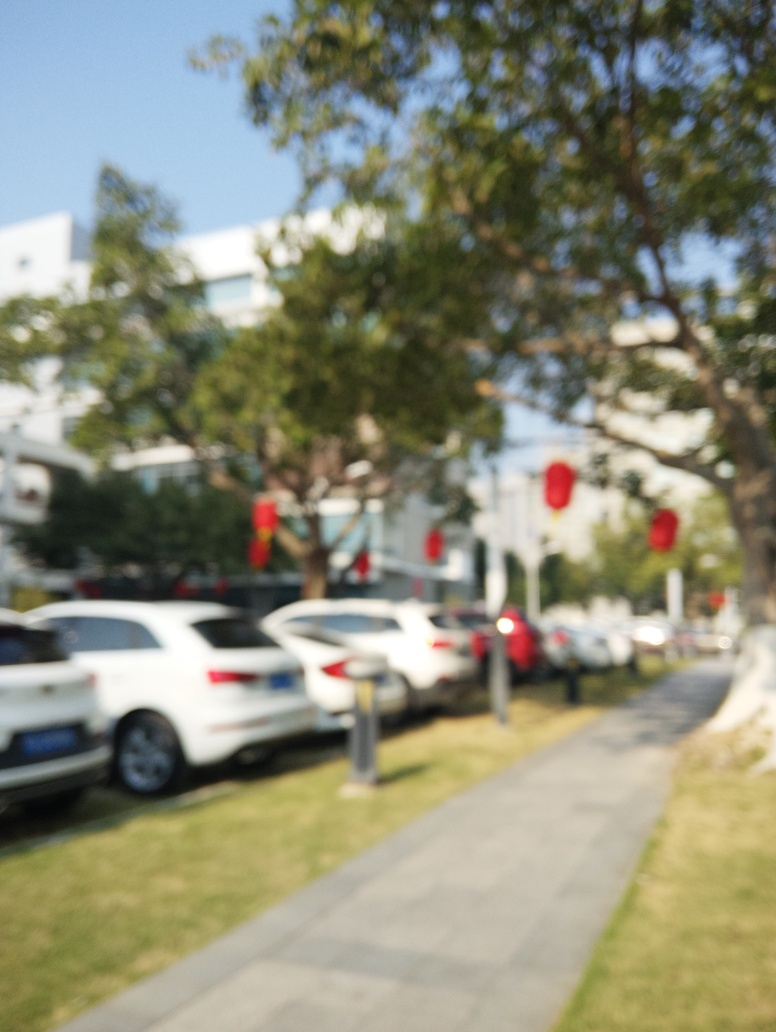Can you suggest how the composition could be improved if the photo were in focus? If the photo were in focus, improving the composition might involve applying the rule of thirds, ensuring that key elements are positioned at the intersections of dividing lines, or balancing the various components within the frame for a harmonious visual experience. 